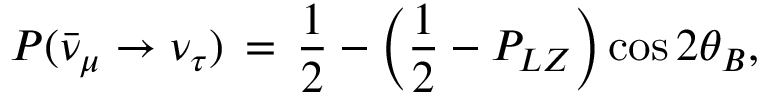<formula> <loc_0><loc_0><loc_500><loc_500>P ( \bar { \nu } _ { \mu } \rightarrow \nu _ { \tau } ) \, = \, \frac { 1 } { 2 } - \left ( \frac { 1 } { 2 } - P _ { L Z } \right ) \cos 2 \theta _ { B } ,</formula> 